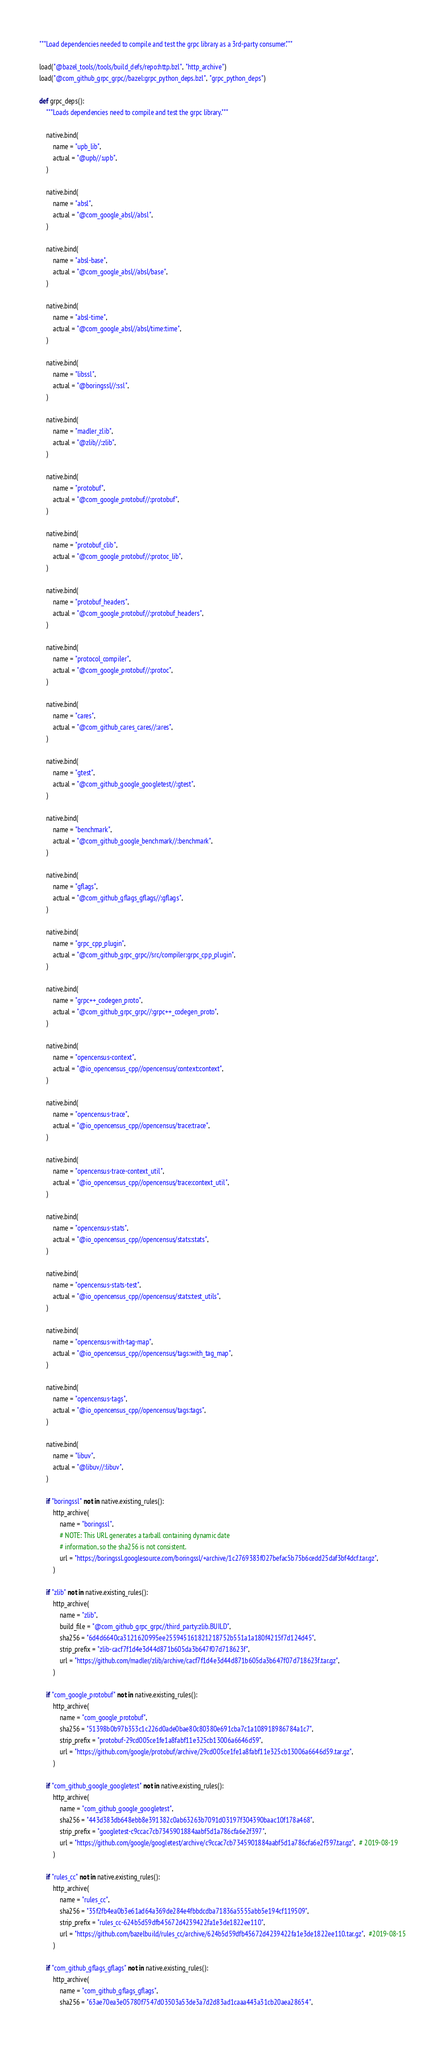Convert code to text. <code><loc_0><loc_0><loc_500><loc_500><_Python_>"""Load dependencies needed to compile and test the grpc library as a 3rd-party consumer."""

load("@bazel_tools//tools/build_defs/repo:http.bzl", "http_archive")
load("@com_github_grpc_grpc//bazel:grpc_python_deps.bzl", "grpc_python_deps")

def grpc_deps():
    """Loads dependencies need to compile and test the grpc library."""

    native.bind(
        name = "upb_lib",
        actual = "@upb//:upb",
    )

    native.bind(
        name = "absl",
        actual = "@com_google_absl//absl",
    )

    native.bind(
        name = "absl-base",
        actual = "@com_google_absl//absl/base",
    )

    native.bind(
        name = "absl-time",
        actual = "@com_google_absl//absl/time:time",
    )

    native.bind(
        name = "libssl",
        actual = "@boringssl//:ssl",
    )

    native.bind(
        name = "madler_zlib",
        actual = "@zlib//:zlib",
    )

    native.bind(
        name = "protobuf",
        actual = "@com_google_protobuf//:protobuf",
    )

    native.bind(
        name = "protobuf_clib",
        actual = "@com_google_protobuf//:protoc_lib",
    )

    native.bind(
        name = "protobuf_headers",
        actual = "@com_google_protobuf//:protobuf_headers",
    )

    native.bind(
        name = "protocol_compiler",
        actual = "@com_google_protobuf//:protoc",
    )

    native.bind(
        name = "cares",
        actual = "@com_github_cares_cares//:ares",
    )

    native.bind(
        name = "gtest",
        actual = "@com_github_google_googletest//:gtest",
    )

    native.bind(
        name = "benchmark",
        actual = "@com_github_google_benchmark//:benchmark",
    )

    native.bind(
        name = "gflags",
        actual = "@com_github_gflags_gflags//:gflags",
    )

    native.bind(
        name = "grpc_cpp_plugin",
        actual = "@com_github_grpc_grpc//src/compiler:grpc_cpp_plugin",
    )

    native.bind(
        name = "grpc++_codegen_proto",
        actual = "@com_github_grpc_grpc//:grpc++_codegen_proto",
    )

    native.bind(
        name = "opencensus-context",
        actual = "@io_opencensus_cpp//opencensus/context:context",
    )

    native.bind(
        name = "opencensus-trace",
        actual = "@io_opencensus_cpp//opencensus/trace:trace",
    )

    native.bind(
        name = "opencensus-trace-context_util",
        actual = "@io_opencensus_cpp//opencensus/trace:context_util",
    )

    native.bind(
        name = "opencensus-stats",
        actual = "@io_opencensus_cpp//opencensus/stats:stats",
    )

    native.bind(
        name = "opencensus-stats-test",
        actual = "@io_opencensus_cpp//opencensus/stats:test_utils",
    )

    native.bind(
        name = "opencensus-with-tag-map",
        actual = "@io_opencensus_cpp//opencensus/tags:with_tag_map",
    )

    native.bind(
        name = "opencensus-tags",
        actual = "@io_opencensus_cpp//opencensus/tags:tags",
    )

    native.bind(
        name = "libuv",
        actual = "@libuv//:libuv",
    )

    if "boringssl" not in native.existing_rules():
        http_archive(
            name = "boringssl",
            # NOTE: This URL generates a tarball containing dynamic date
            # information, so the sha256 is not consistent.
            url = "https://boringssl.googlesource.com/boringssl/+archive/1c2769383f027befac5b75b6cedd25daf3bf4dcf.tar.gz",
        )

    if "zlib" not in native.existing_rules():
        http_archive(
            name = "zlib",
            build_file = "@com_github_grpc_grpc//third_party:zlib.BUILD",
            sha256 = "6d4d6640ca3121620995ee255945161821218752b551a1a180f4215f7d124d45",
            strip_prefix = "zlib-cacf7f1d4e3d44d871b605da3b647f07d718623f",
            url = "https://github.com/madler/zlib/archive/cacf7f1d4e3d44d871b605da3b647f07d718623f.tar.gz",
        )

    if "com_google_protobuf" not in native.existing_rules():
        http_archive(
            name = "com_google_protobuf",
            sha256 = "51398b0b97b353c1c226d0ade0bae80c80380e691cba7c1a108918986784a1c7",
            strip_prefix = "protobuf-29cd005ce1fe1a8fabf11e325cb13006a6646d59",
            url = "https://github.com/google/protobuf/archive/29cd005ce1fe1a8fabf11e325cb13006a6646d59.tar.gz",
        )

    if "com_github_google_googletest" not in native.existing_rules():
        http_archive(
            name = "com_github_google_googletest",
            sha256 = "443d383db648ebb8e391382c0ab63263b7091d03197f304390baac10f178a468",
            strip_prefix = "googletest-c9ccac7cb7345901884aabf5d1a786cfa6e2f397",
            url = "https://github.com/google/googletest/archive/c9ccac7cb7345901884aabf5d1a786cfa6e2f397.tar.gz",  # 2019-08-19
        )

    if "rules_cc" not in native.existing_rules():
        http_archive(
            name = "rules_cc",
            sha256 = "35f2fb4ea0b3e61ad64a369de284e4fbbdcdba71836a5555abb5e194cf119509",
            strip_prefix = "rules_cc-624b5d59dfb45672d4239422fa1e3de1822ee110",
            url = "https://github.com/bazelbuild/rules_cc/archive/624b5d59dfb45672d4239422fa1e3de1822ee110.tar.gz",  #2019-08-15
        )

    if "com_github_gflags_gflags" not in native.existing_rules():
        http_archive(
            name = "com_github_gflags_gflags",
            sha256 = "63ae70ea3e05780f7547d03503a53de3a7d2d83ad1caaa443a31cb20aea28654",</code> 